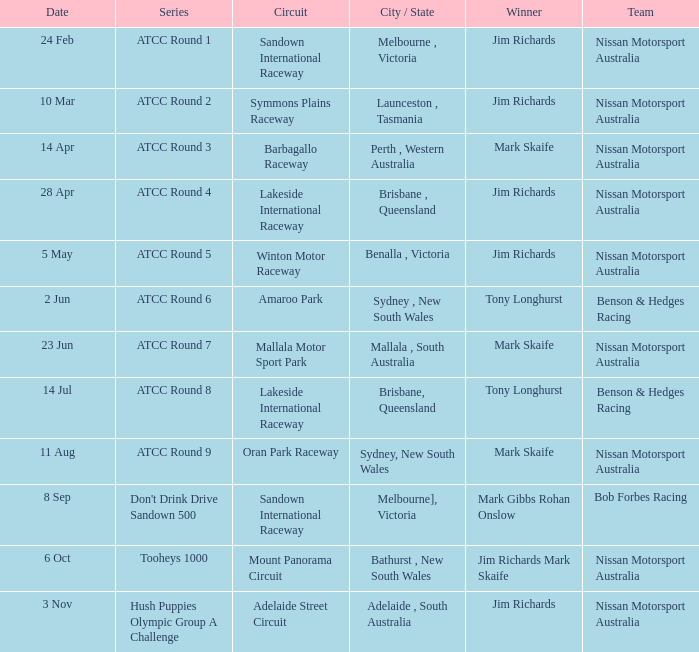Who is the Winner of the Nissan Motorsport Australia Team at the Oran Park Raceway? Mark Skaife. 